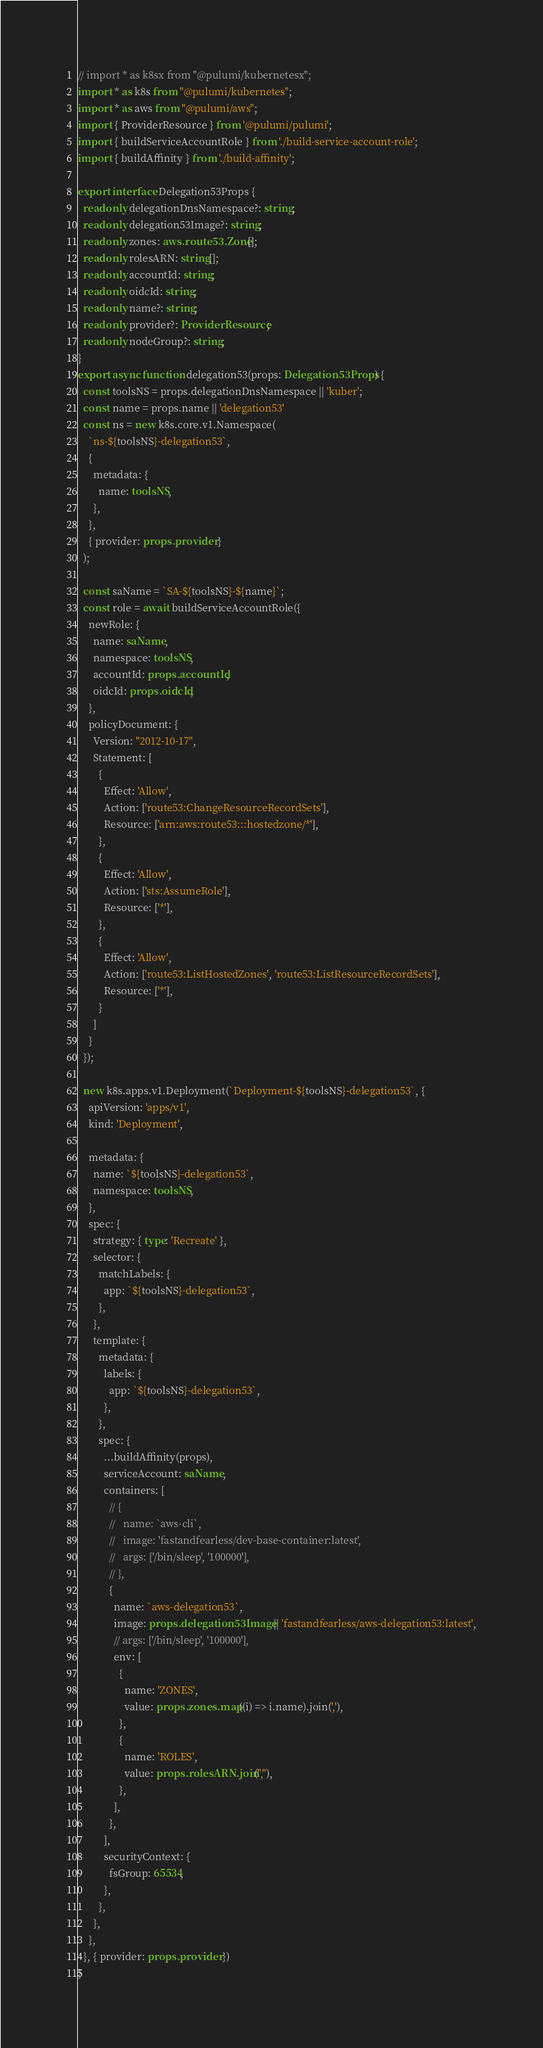Convert code to text. <code><loc_0><loc_0><loc_500><loc_500><_TypeScript_>// import * as k8sx from "@pulumi/kubernetesx";
import * as k8s from "@pulumi/kubernetes";
import * as aws from "@pulumi/aws";
import { ProviderResource } from '@pulumi/pulumi';
import { buildServiceAccountRole } from './build-service-account-role';
import { buildAffinity } from './build-affinity';

export interface Delegation53Props {
  readonly delegationDnsNamespace?: string;
  readonly delegation53Image?: string;
  readonly zones: aws.route53.Zone[];
  readonly rolesARN: string[];
  readonly accountId: string;
  readonly oidcId: string;
  readonly name?: string;
  readonly provider?: ProviderResource;
  readonly nodeGroup?: string;
}
export async function delegation53(props: Delegation53Props) {
  const toolsNS = props.delegationDnsNamespace || 'kuber';
  const name = props.name || 'delegation53'
  const ns = new k8s.core.v1.Namespace(
    `ns-${toolsNS}-delegation53`,
    {
      metadata: {
        name: toolsNS,
      },
    },
    { provider: props.provider }
  );

  const saName = `SA-${toolsNS}-${name}`;
  const role = await buildServiceAccountRole({
    newRole: {
      name: saName,
      namespace: toolsNS,
      accountId: props.accountId,
      oidcId: props.oidcId,
    },
    policyDocument: {
      Version: "2012-10-17",
      Statement: [
        {
          Effect: 'Allow',
          Action: ['route53:ChangeResourceRecordSets'],
          Resource: ['arn:aws:route53:::hostedzone/*'],
        },
        {
          Effect: 'Allow',
          Action: ['sts:AssumeRole'],
          Resource: ['*'],
        },
        {
          Effect: 'Allow',
          Action: ['route53:ListHostedZones', 'route53:ListResourceRecordSets'],
          Resource: ['*'],
        }
      ]
    }
  });

  new k8s.apps.v1.Deployment(`Deployment-${toolsNS}-delegation53`, {
    apiVersion: 'apps/v1',
    kind: 'Deployment',

    metadata: {
      name: `${toolsNS}-delegation53`,
      namespace: toolsNS,
    },
    spec: {
      strategy: { type: 'Recreate' },
      selector: {
        matchLabels: {
          app: `${toolsNS}-delegation53`,
        },
      },
      template: {
        metadata: {
          labels: {
            app: `${toolsNS}-delegation53`,
          },
        },
        spec: {
          ...buildAffinity(props),
          serviceAccount: saName,
          containers: [
            // {
            //   name: `aws-cli`,
            //   image: 'fastandfearless/dev-base-container:latest',
            //   args: ['/bin/sleep', '100000'],
            // },
            {
              name: `aws-delegation53`,
              image: props.delegation53Image || 'fastandfearless/aws-delegation53:latest',
              // args: ['/bin/sleep', '100000'],
              env: [
                {
                  name: 'ZONES',
                  value: props.zones.map((i) => i.name).join(','),
                },
                {
                  name: 'ROLES',
                  value: props.rolesARN.join(","),
                },
              ],
            },
          ],
          securityContext: {
            fsGroup: 65534,
          },
        },
      },
    },
  }, { provider: props.provider })
}
</code> 